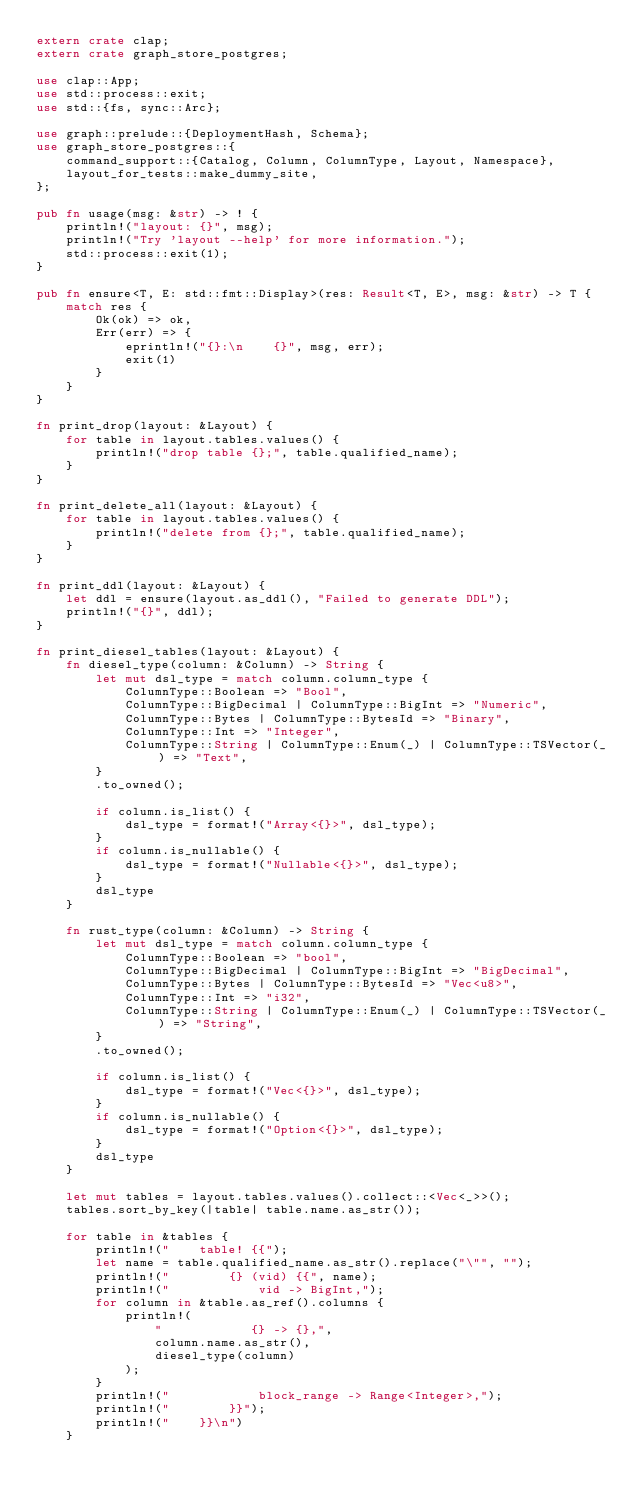<code> <loc_0><loc_0><loc_500><loc_500><_Rust_>extern crate clap;
extern crate graph_store_postgres;

use clap::App;
use std::process::exit;
use std::{fs, sync::Arc};

use graph::prelude::{DeploymentHash, Schema};
use graph_store_postgres::{
    command_support::{Catalog, Column, ColumnType, Layout, Namespace},
    layout_for_tests::make_dummy_site,
};

pub fn usage(msg: &str) -> ! {
    println!("layout: {}", msg);
    println!("Try 'layout --help' for more information.");
    std::process::exit(1);
}

pub fn ensure<T, E: std::fmt::Display>(res: Result<T, E>, msg: &str) -> T {
    match res {
        Ok(ok) => ok,
        Err(err) => {
            eprintln!("{}:\n    {}", msg, err);
            exit(1)
        }
    }
}

fn print_drop(layout: &Layout) {
    for table in layout.tables.values() {
        println!("drop table {};", table.qualified_name);
    }
}

fn print_delete_all(layout: &Layout) {
    for table in layout.tables.values() {
        println!("delete from {};", table.qualified_name);
    }
}

fn print_ddl(layout: &Layout) {
    let ddl = ensure(layout.as_ddl(), "Failed to generate DDL");
    println!("{}", ddl);
}

fn print_diesel_tables(layout: &Layout) {
    fn diesel_type(column: &Column) -> String {
        let mut dsl_type = match column.column_type {
            ColumnType::Boolean => "Bool",
            ColumnType::BigDecimal | ColumnType::BigInt => "Numeric",
            ColumnType::Bytes | ColumnType::BytesId => "Binary",
            ColumnType::Int => "Integer",
            ColumnType::String | ColumnType::Enum(_) | ColumnType::TSVector(_) => "Text",
        }
        .to_owned();

        if column.is_list() {
            dsl_type = format!("Array<{}>", dsl_type);
        }
        if column.is_nullable() {
            dsl_type = format!("Nullable<{}>", dsl_type);
        }
        dsl_type
    }

    fn rust_type(column: &Column) -> String {
        let mut dsl_type = match column.column_type {
            ColumnType::Boolean => "bool",
            ColumnType::BigDecimal | ColumnType::BigInt => "BigDecimal",
            ColumnType::Bytes | ColumnType::BytesId => "Vec<u8>",
            ColumnType::Int => "i32",
            ColumnType::String | ColumnType::Enum(_) | ColumnType::TSVector(_) => "String",
        }
        .to_owned();

        if column.is_list() {
            dsl_type = format!("Vec<{}>", dsl_type);
        }
        if column.is_nullable() {
            dsl_type = format!("Option<{}>", dsl_type);
        }
        dsl_type
    }

    let mut tables = layout.tables.values().collect::<Vec<_>>();
    tables.sort_by_key(|table| table.name.as_str());

    for table in &tables {
        println!("    table! {{");
        let name = table.qualified_name.as_str().replace("\"", "");
        println!("        {} (vid) {{", name);
        println!("            vid -> BigInt,");
        for column in &table.as_ref().columns {
            println!(
                "            {} -> {},",
                column.name.as_str(),
                diesel_type(column)
            );
        }
        println!("            block_range -> Range<Integer>,");
        println!("        }}");
        println!("    }}\n")
    }
</code> 